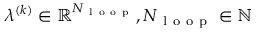<formula> <loc_0><loc_0><loc_500><loc_500>\lambda ^ { ( k ) } \in \mathbb { R } ^ { N _ { l o o p } } , N _ { l o o p } \in \mathbb { N }</formula> 